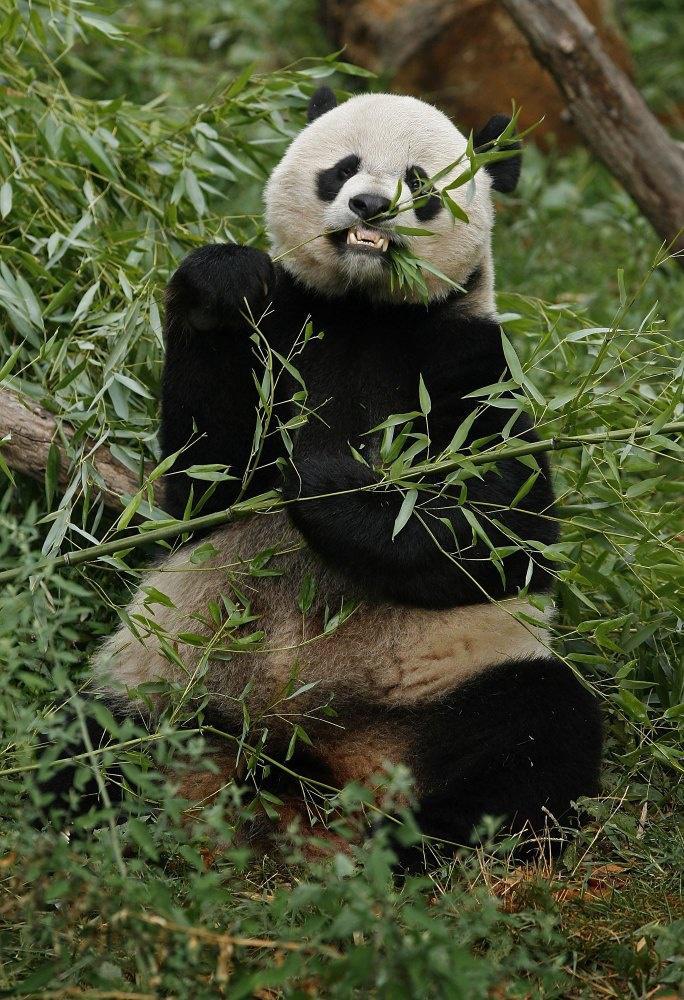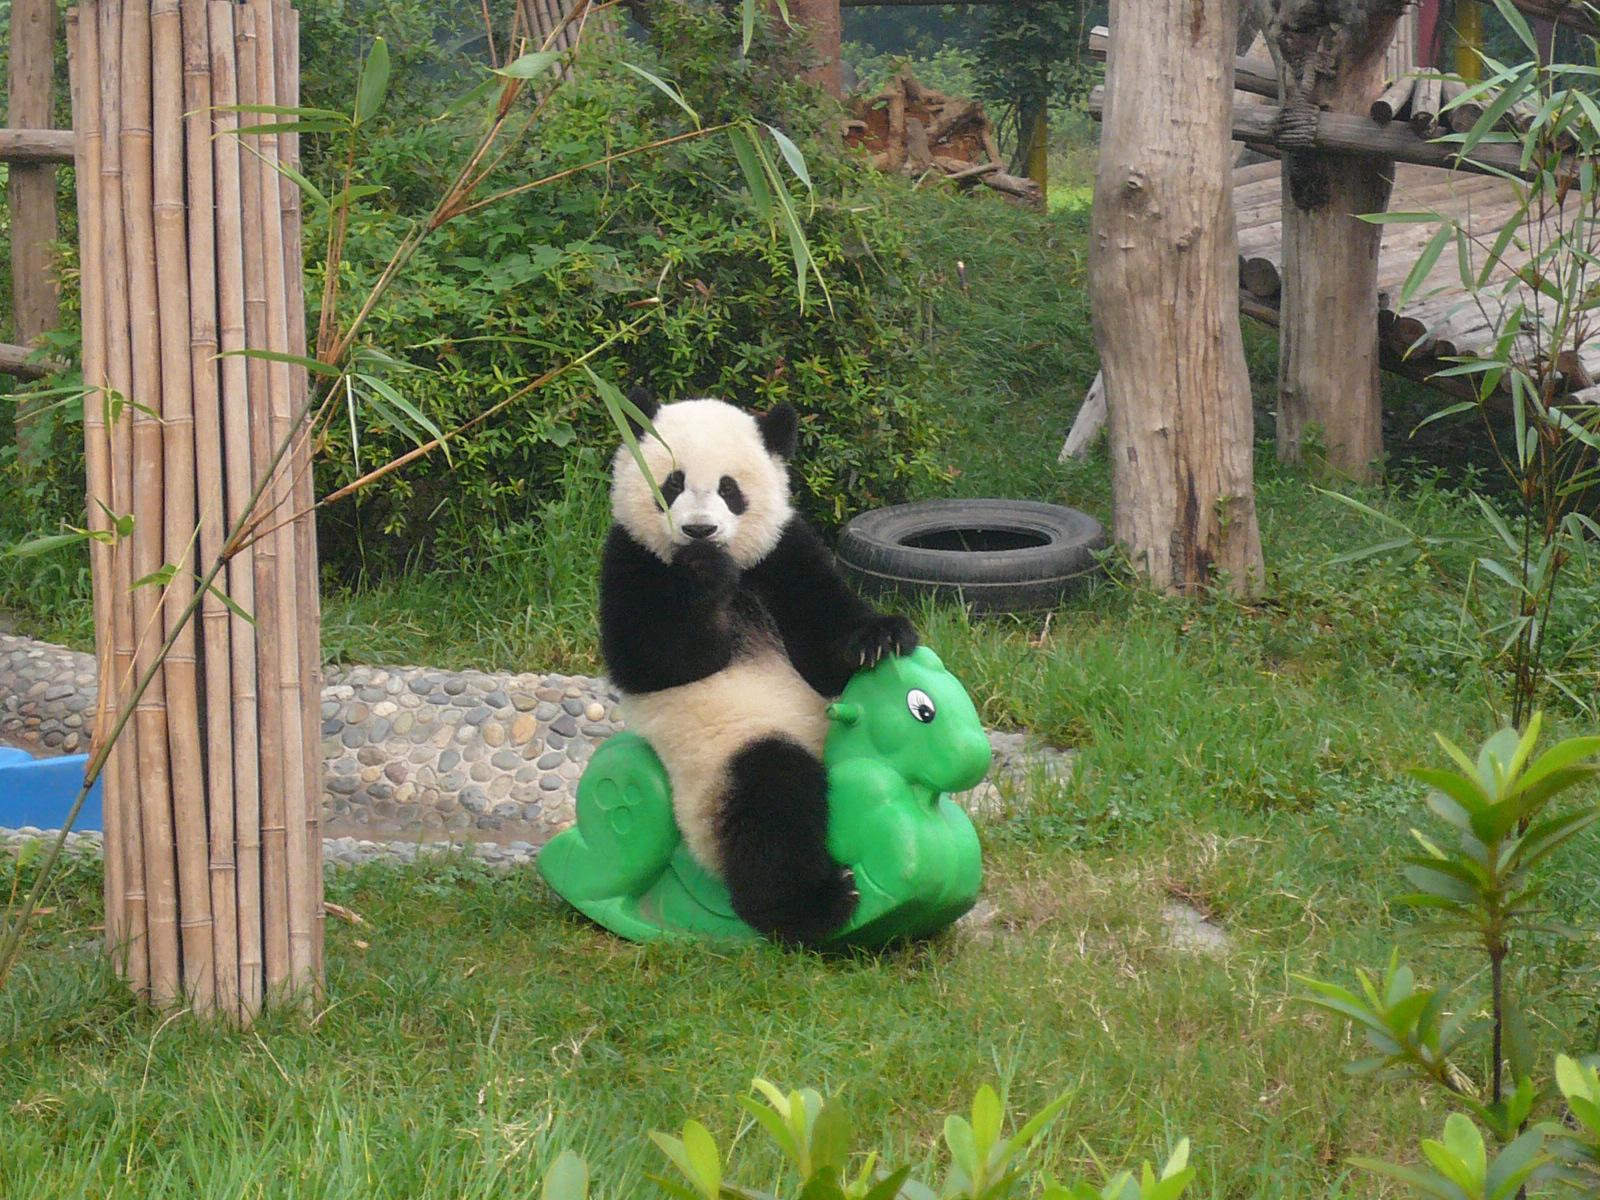The first image is the image on the left, the second image is the image on the right. Evaluate the accuracy of this statement regarding the images: "An image shows exactly one panda, which is sitting and nibbling on a leafy stalk.". Is it true? Answer yes or no. Yes. The first image is the image on the left, the second image is the image on the right. Assess this claim about the two images: "There are at least six pandas.". Correct or not? Answer yes or no. No. 